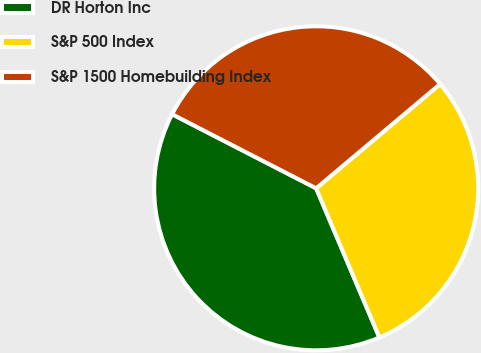Convert chart to OTSL. <chart><loc_0><loc_0><loc_500><loc_500><pie_chart><fcel>DR Horton Inc<fcel>S&P 500 Index<fcel>S&P 1500 Homebuilding Index<nl><fcel>38.94%<fcel>29.75%<fcel>31.31%<nl></chart> 